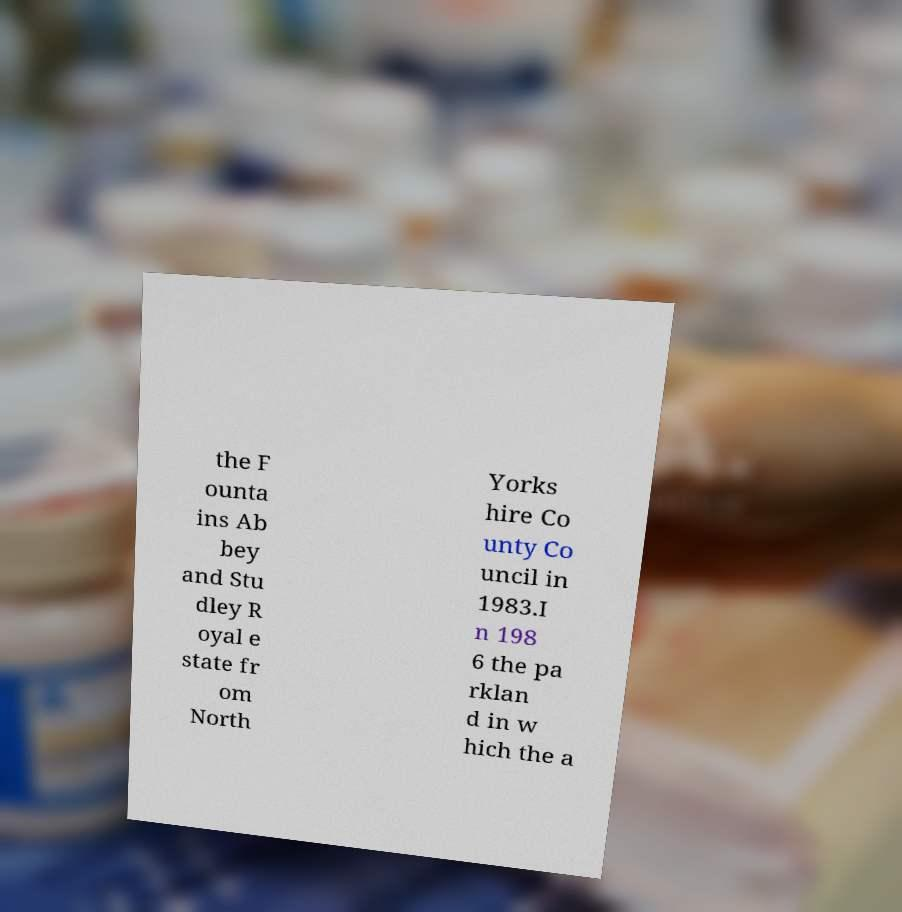What messages or text are displayed in this image? I need them in a readable, typed format. the F ounta ins Ab bey and Stu dley R oyal e state fr om North Yorks hire Co unty Co uncil in 1983.I n 198 6 the pa rklan d in w hich the a 